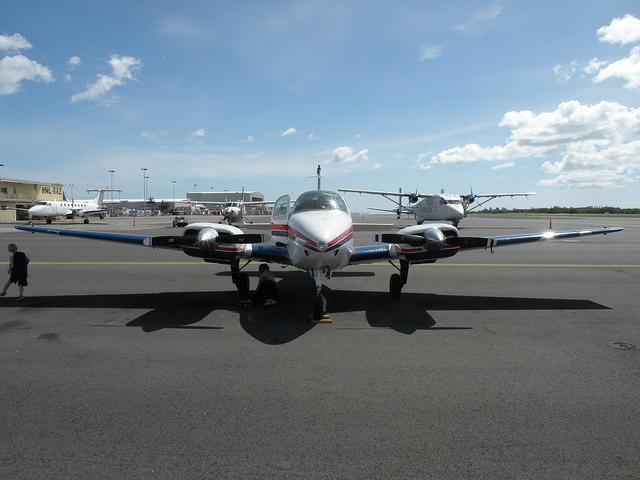How many airplanes are there in this image?
Give a very brief answer. 4. How many airplanes are visible?
Give a very brief answer. 2. 